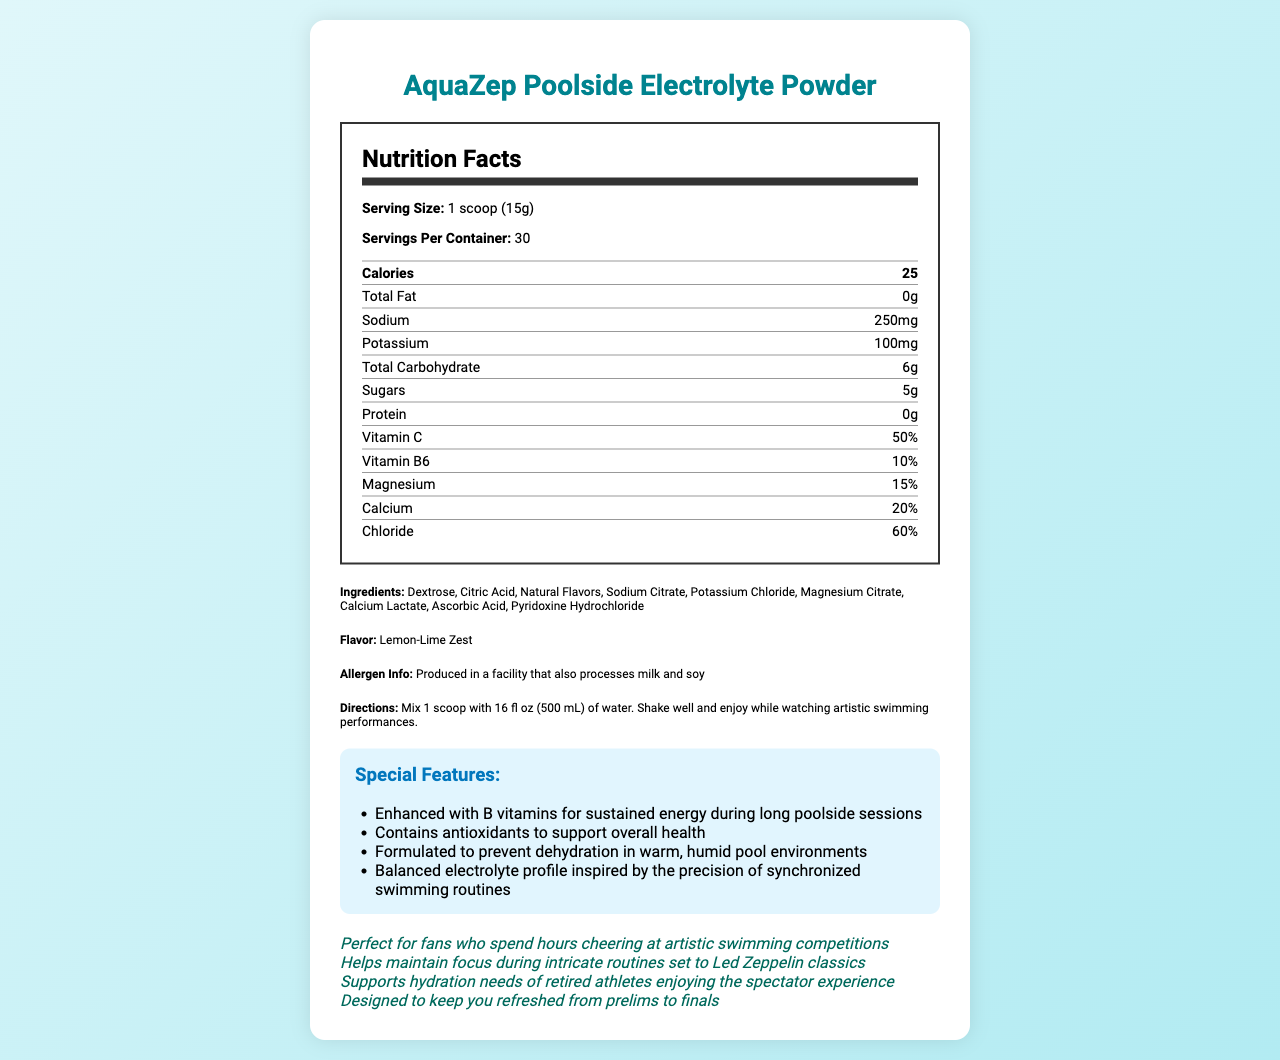what is the serving size of AquaZep Poolside Electrolyte Powder? The serving size is specified in the nutrition facts section of the document.
Answer: 1 scoop (15g) how many calories are in one serving? The calories per serving are listed in the nutrition facts table.
Answer: 25 calories how much sodium is in one serving of the powder? The sodium content per serving is given in the nutrition facts table.
Answer: 250mg what flavor is the AquaZep Poolside Electrolyte Powder? The flavor is mentioned under the ingredients section.
Answer: Lemon-Lime Zest what are the total carbohydrates in one serving of the powder? The total carbohydrates per serving are listed in the nutrition facts table.
Answer: 6g which ingredient is used to provide the sweetness? A. Sodium Citrate B. Dextrose C. Pyridoxine Hydrochloride Dextrose is a type of sugar, making it the ingredient used to provide sweetness.
Answer: B. Dextrose which vitamins are included in AquaZep Poolside Electrolyte Powder? A. Vitamin A and Vitamin D B. Vitamin C and Vitamin B6 C. Vitamin E and Vitamin K D. Vitamin B12 and Vitamin D The vitamins listed in the nutrition facts table are Vitamin C and Vitamin B6.
Answer: B. Vitamin C and Vitamin B6 how many servings are in one container? The number of servings per container is specified in the document.
Answer: 30 servings does the powder contain any protein? The protein content listed in the nutrition facts table is 0g.
Answer: No is the AquaZep Poolside Electrolyte Powder safe for someone with a soy allergy? The allergen information states that the product is produced in a facility that also processes soy.
Answer: No summarize the main purpose of this document. The document includes various sections such as serving size, ingredients, nutritional values, special features, and marketing claims, all aimed at informing the consumer about the product's benefits and uses.
Answer: This document provides detailed nutrition facts, ingredients, special features, and marketing claims for AquaZep Poolside Electrolyte Powder, a hydration-boosting drink designed for poolside spectators, with a focus on maintaining hydration and energy during long artistic swimming competitions. what is the primary focus of the marketing claims section? The marketing claims highlight how the product is perfect for fans cheering at artistic swimming competitions, helps maintain focus during routines, and supports hydration for retired athletes.
Answer: To promote the product's suitability for poolside spectators, especially fans of artistic swimming and retired athletes. how much sugar is in one scoop of the powder? The amount of sugar per serving is listed as 5g in the nutrition facts table.
Answer: 5g which of the following minerals are included in the powder? A. Iron and Zinc B. Magnesium and Calcium C. Potassium and Phosphorus The nutrition facts table lists Magnesium and Calcium as minerals included in the powder.
Answer: B. Magnesium and Calcium can the serving size be adjusted by mixing it with more water? The directions specify mixing 1 scoop with 16 fl oz of water, but there is no information about adjusting the serving size by mixing it with more water.
Answer: Cannot be determined what special features does the AquaZep Poolside Electrolyte Powder offer? The special features section lists these benefits aimed at maintaining hydration and energy.
Answer: Enhanced with B vitamins for sustained energy, contains antioxidants, formulated to prevent dehydration, balanced electrolyte profile. 